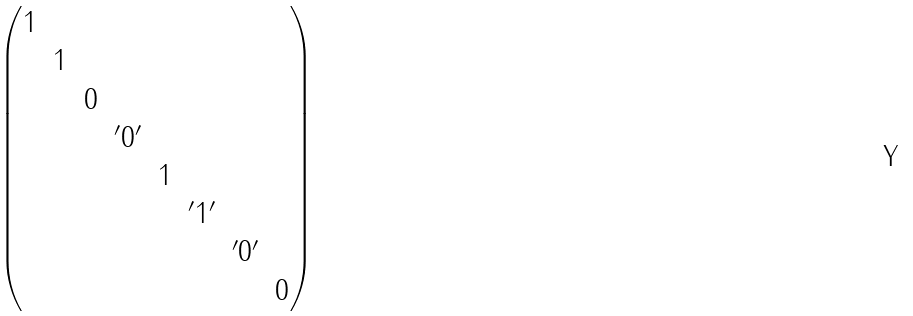Convert formula to latex. <formula><loc_0><loc_0><loc_500><loc_500>\begin{pmatrix} 1 & & & & & & & \\ & 1 & & & & & & \\ & & 0 & & & & & \\ & & & ^ { \prime } 0 ^ { \prime } & & & & \\ & & & & 1 & & & \\ & & & & & ^ { \prime } 1 ^ { \prime } & & \\ & & & & & & ^ { \prime } 0 ^ { \prime } & \\ & & & & & & & 0 \end{pmatrix}</formula> 